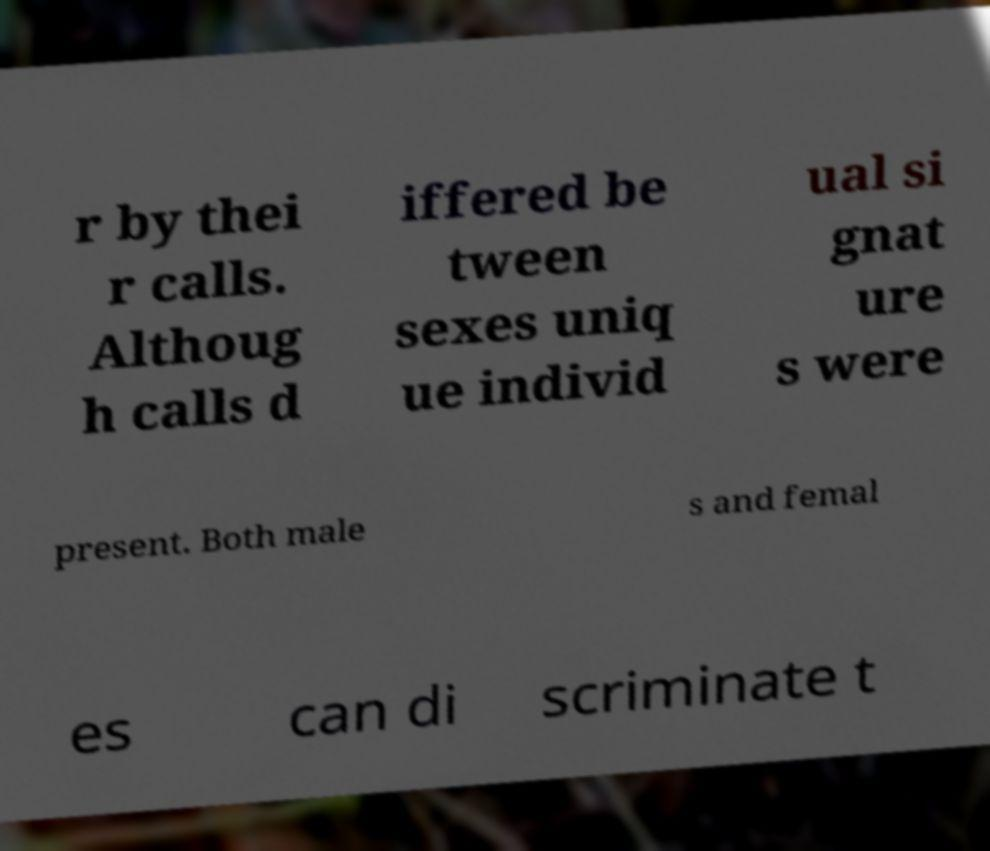There's text embedded in this image that I need extracted. Can you transcribe it verbatim? r by thei r calls. Althoug h calls d iffered be tween sexes uniq ue individ ual si gnat ure s were present. Both male s and femal es can di scriminate t 